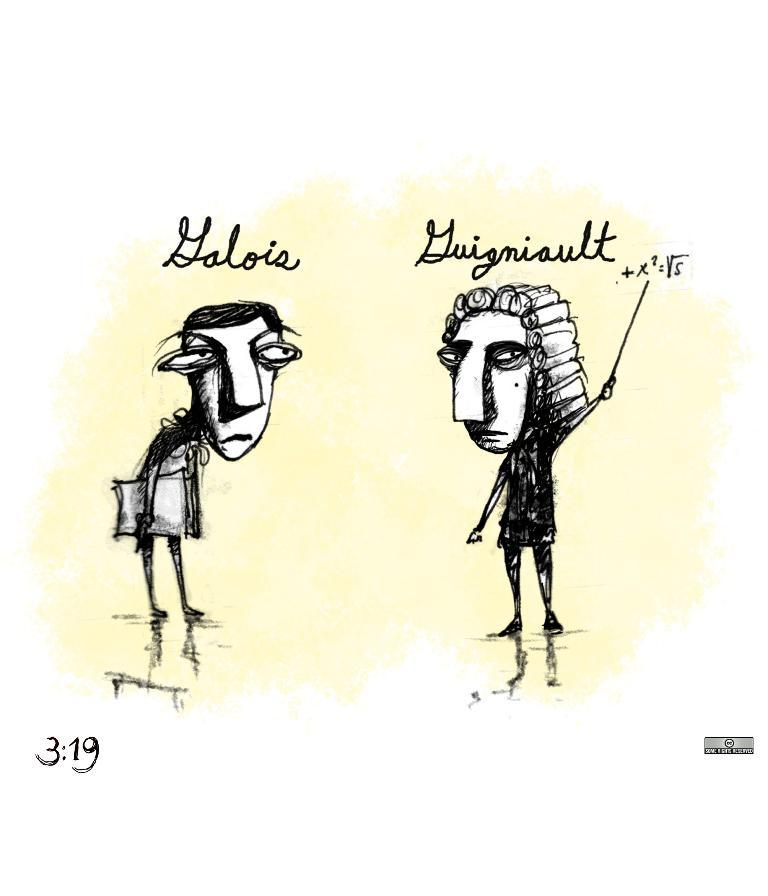What is depicted in the image? There is a sketch of two persons in the image. Can you describe the text in the image? There is some text in the middle of the image. What type of yak can be seen in the image? There is no yak present in the image; it features a sketch of two persons and some text. What kind of error is visible in the image? There is no error visible in the image; it contains a sketch of two persons and some text. 